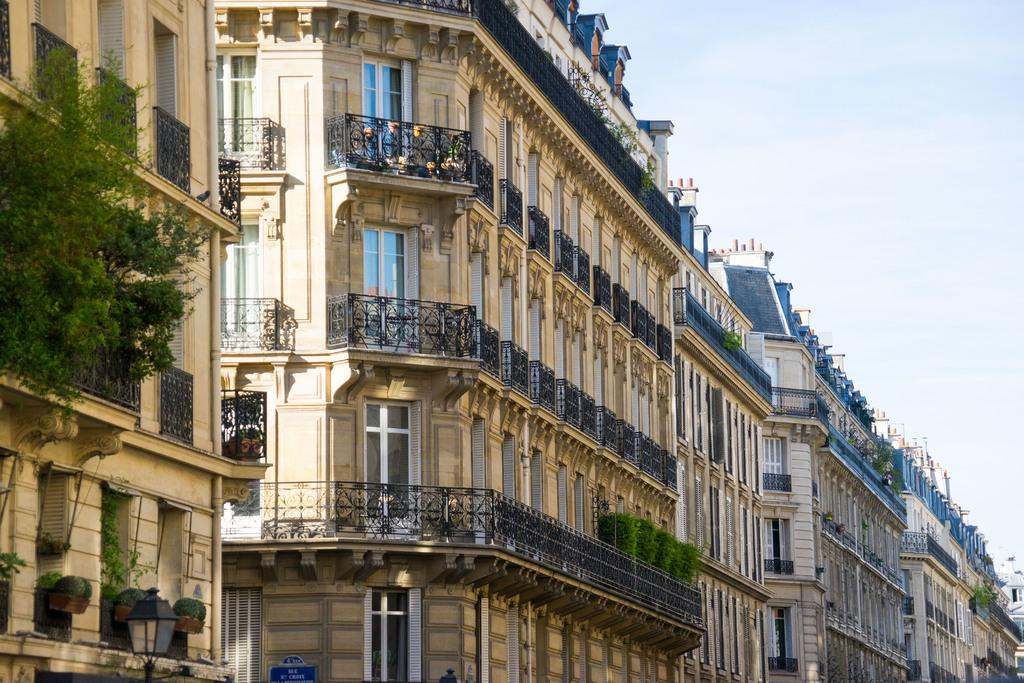What type of structures can be seen in the image? There are buildings in the image. What other elements are present in the image besides buildings? There are plants and a board at the bottom of the image. What can be seen in the background of the image? The sky is visible in the background of the image. How many badges can be seen on the plants in the image? There are no badges present on the plants in the image. Can you describe the trail that the buildings are following in the image? There is no trail visible in the image; the buildings are stationary structures. 